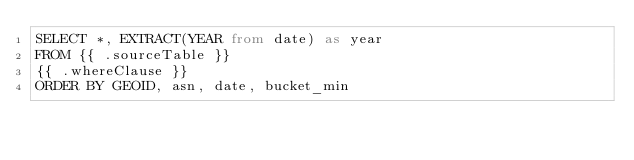Convert code to text. <code><loc_0><loc_0><loc_500><loc_500><_SQL_>SELECT *, EXTRACT(YEAR from date) as year
FROM {{ .sourceTable }}
{{ .whereClause }}
ORDER BY GEOID, asn, date, bucket_min</code> 